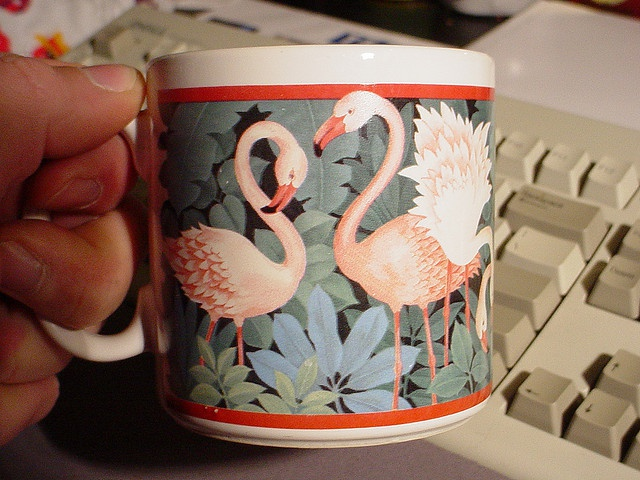Describe the objects in this image and their specific colors. I can see cup in maroon, darkgray, lightgray, black, and gray tones, keyboard in maroon, tan, and gray tones, people in maroon, black, and brown tones, bird in maroon, tan, and brown tones, and bird in maroon, lightgray, tan, and darkgray tones in this image. 